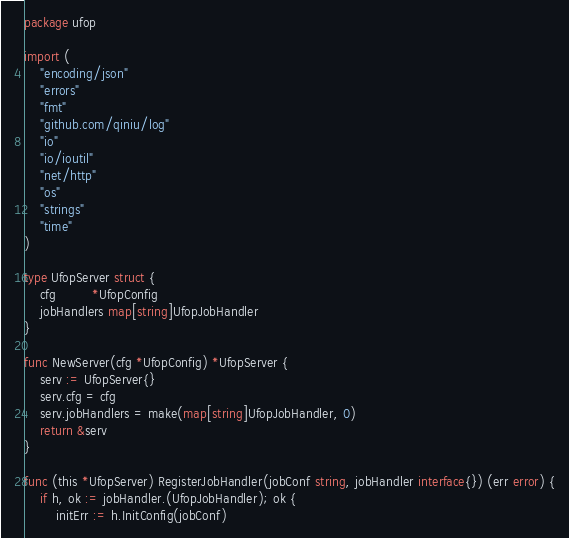Convert code to text. <code><loc_0><loc_0><loc_500><loc_500><_Go_>package ufop

import (
	"encoding/json"
	"errors"
	"fmt"
	"github.com/qiniu/log"
	"io"
	"io/ioutil"
	"net/http"
	"os"
	"strings"
	"time"
)

type UfopServer struct {
	cfg         *UfopConfig
	jobHandlers map[string]UfopJobHandler
}

func NewServer(cfg *UfopConfig) *UfopServer {
	serv := UfopServer{}
	serv.cfg = cfg
	serv.jobHandlers = make(map[string]UfopJobHandler, 0)
	return &serv
}

func (this *UfopServer) RegisterJobHandler(jobConf string, jobHandler interface{}) (err error) {
	if h, ok := jobHandler.(UfopJobHandler); ok {
		initErr := h.InitConfig(jobConf)</code> 